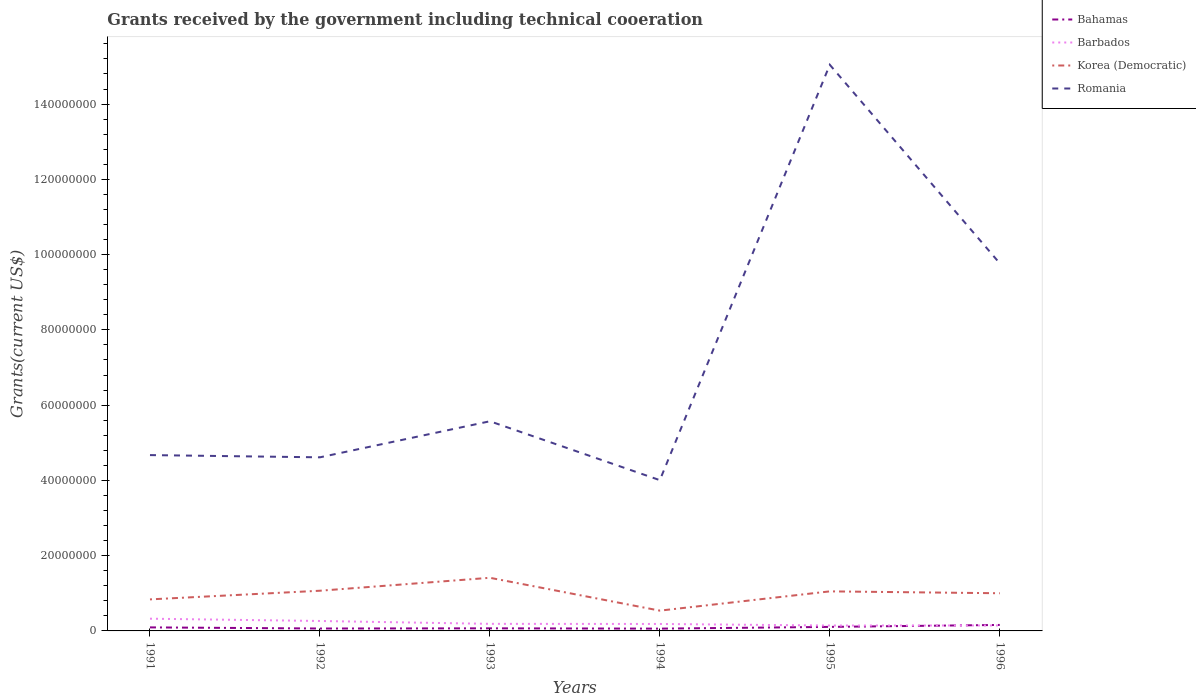Does the line corresponding to Bahamas intersect with the line corresponding to Korea (Democratic)?
Your answer should be very brief. No. Is the number of lines equal to the number of legend labels?
Offer a terse response. Yes. Across all years, what is the maximum total grants received by the government in Barbados?
Your answer should be very brief. 1.43e+06. What is the total total grants received by the government in Romania in the graph?
Offer a terse response. -9.47e+07. What is the difference between the highest and the second highest total grants received by the government in Barbados?
Your answer should be compact. 1.82e+06. What is the difference between the highest and the lowest total grants received by the government in Korea (Democratic)?
Your answer should be compact. 4. Is the total grants received by the government in Korea (Democratic) strictly greater than the total grants received by the government in Barbados over the years?
Provide a succinct answer. No. How are the legend labels stacked?
Keep it short and to the point. Vertical. What is the title of the graph?
Keep it short and to the point. Grants received by the government including technical cooeration. Does "Caribbean small states" appear as one of the legend labels in the graph?
Make the answer very short. No. What is the label or title of the X-axis?
Your response must be concise. Years. What is the label or title of the Y-axis?
Provide a succinct answer. Grants(current US$). What is the Grants(current US$) of Bahamas in 1991?
Keep it short and to the point. 9.40e+05. What is the Grants(current US$) in Barbados in 1991?
Provide a succinct answer. 3.25e+06. What is the Grants(current US$) in Korea (Democratic) in 1991?
Give a very brief answer. 8.38e+06. What is the Grants(current US$) of Romania in 1991?
Offer a very short reply. 4.67e+07. What is the Grants(current US$) in Bahamas in 1992?
Provide a succinct answer. 6.40e+05. What is the Grants(current US$) in Barbados in 1992?
Your response must be concise. 2.64e+06. What is the Grants(current US$) of Korea (Democratic) in 1992?
Give a very brief answer. 1.07e+07. What is the Grants(current US$) in Romania in 1992?
Offer a very short reply. 4.61e+07. What is the Grants(current US$) in Bahamas in 1993?
Give a very brief answer. 6.90e+05. What is the Grants(current US$) in Barbados in 1993?
Ensure brevity in your answer.  1.88e+06. What is the Grants(current US$) in Korea (Democratic) in 1993?
Provide a succinct answer. 1.41e+07. What is the Grants(current US$) of Romania in 1993?
Keep it short and to the point. 5.57e+07. What is the Grants(current US$) of Bahamas in 1994?
Your answer should be very brief. 6.10e+05. What is the Grants(current US$) of Barbados in 1994?
Your answer should be very brief. 1.85e+06. What is the Grants(current US$) of Korea (Democratic) in 1994?
Ensure brevity in your answer.  5.39e+06. What is the Grants(current US$) of Romania in 1994?
Keep it short and to the point. 4.01e+07. What is the Grants(current US$) of Bahamas in 1995?
Provide a succinct answer. 1.07e+06. What is the Grants(current US$) in Barbados in 1995?
Your answer should be very brief. 1.43e+06. What is the Grants(current US$) in Korea (Democratic) in 1995?
Your answer should be compact. 1.05e+07. What is the Grants(current US$) in Romania in 1995?
Offer a terse response. 1.50e+08. What is the Grants(current US$) in Bahamas in 1996?
Give a very brief answer. 1.59e+06. What is the Grants(current US$) of Barbados in 1996?
Ensure brevity in your answer.  1.45e+06. What is the Grants(current US$) in Korea (Democratic) in 1996?
Give a very brief answer. 1.00e+07. What is the Grants(current US$) in Romania in 1996?
Your answer should be very brief. 9.77e+07. Across all years, what is the maximum Grants(current US$) in Bahamas?
Provide a succinct answer. 1.59e+06. Across all years, what is the maximum Grants(current US$) of Barbados?
Ensure brevity in your answer.  3.25e+06. Across all years, what is the maximum Grants(current US$) of Korea (Democratic)?
Provide a short and direct response. 1.41e+07. Across all years, what is the maximum Grants(current US$) of Romania?
Make the answer very short. 1.50e+08. Across all years, what is the minimum Grants(current US$) in Bahamas?
Make the answer very short. 6.10e+05. Across all years, what is the minimum Grants(current US$) of Barbados?
Provide a succinct answer. 1.43e+06. Across all years, what is the minimum Grants(current US$) in Korea (Democratic)?
Provide a succinct answer. 5.39e+06. Across all years, what is the minimum Grants(current US$) in Romania?
Your answer should be very brief. 4.01e+07. What is the total Grants(current US$) of Bahamas in the graph?
Offer a very short reply. 5.54e+06. What is the total Grants(current US$) in Barbados in the graph?
Make the answer very short. 1.25e+07. What is the total Grants(current US$) of Korea (Democratic) in the graph?
Your answer should be compact. 5.91e+07. What is the total Grants(current US$) of Romania in the graph?
Give a very brief answer. 4.37e+08. What is the difference between the Grants(current US$) in Bahamas in 1991 and that in 1992?
Your answer should be very brief. 3.00e+05. What is the difference between the Grants(current US$) in Korea (Democratic) in 1991 and that in 1992?
Your answer should be compact. -2.30e+06. What is the difference between the Grants(current US$) in Romania in 1991 and that in 1992?
Offer a terse response. 5.90e+05. What is the difference between the Grants(current US$) of Bahamas in 1991 and that in 1993?
Offer a terse response. 2.50e+05. What is the difference between the Grants(current US$) of Barbados in 1991 and that in 1993?
Give a very brief answer. 1.37e+06. What is the difference between the Grants(current US$) in Korea (Democratic) in 1991 and that in 1993?
Offer a very short reply. -5.74e+06. What is the difference between the Grants(current US$) of Romania in 1991 and that in 1993?
Provide a short and direct response. -8.99e+06. What is the difference between the Grants(current US$) of Barbados in 1991 and that in 1994?
Your answer should be very brief. 1.40e+06. What is the difference between the Grants(current US$) in Korea (Democratic) in 1991 and that in 1994?
Offer a very short reply. 2.99e+06. What is the difference between the Grants(current US$) in Romania in 1991 and that in 1994?
Ensure brevity in your answer.  6.66e+06. What is the difference between the Grants(current US$) in Bahamas in 1991 and that in 1995?
Keep it short and to the point. -1.30e+05. What is the difference between the Grants(current US$) of Barbados in 1991 and that in 1995?
Offer a terse response. 1.82e+06. What is the difference between the Grants(current US$) of Korea (Democratic) in 1991 and that in 1995?
Give a very brief answer. -2.13e+06. What is the difference between the Grants(current US$) in Romania in 1991 and that in 1995?
Offer a very short reply. -1.04e+08. What is the difference between the Grants(current US$) of Bahamas in 1991 and that in 1996?
Your answer should be very brief. -6.50e+05. What is the difference between the Grants(current US$) in Barbados in 1991 and that in 1996?
Provide a succinct answer. 1.80e+06. What is the difference between the Grants(current US$) of Korea (Democratic) in 1991 and that in 1996?
Your response must be concise. -1.63e+06. What is the difference between the Grants(current US$) in Romania in 1991 and that in 1996?
Your answer should be very brief. -5.10e+07. What is the difference between the Grants(current US$) of Barbados in 1992 and that in 1993?
Keep it short and to the point. 7.60e+05. What is the difference between the Grants(current US$) of Korea (Democratic) in 1992 and that in 1993?
Your response must be concise. -3.44e+06. What is the difference between the Grants(current US$) of Romania in 1992 and that in 1993?
Offer a very short reply. -9.58e+06. What is the difference between the Grants(current US$) in Bahamas in 1992 and that in 1994?
Your answer should be very brief. 3.00e+04. What is the difference between the Grants(current US$) in Barbados in 1992 and that in 1994?
Give a very brief answer. 7.90e+05. What is the difference between the Grants(current US$) in Korea (Democratic) in 1992 and that in 1994?
Provide a short and direct response. 5.29e+06. What is the difference between the Grants(current US$) of Romania in 1992 and that in 1994?
Offer a very short reply. 6.07e+06. What is the difference between the Grants(current US$) in Bahamas in 1992 and that in 1995?
Make the answer very short. -4.30e+05. What is the difference between the Grants(current US$) of Barbados in 1992 and that in 1995?
Provide a succinct answer. 1.21e+06. What is the difference between the Grants(current US$) in Romania in 1992 and that in 1995?
Provide a succinct answer. -1.04e+08. What is the difference between the Grants(current US$) of Bahamas in 1992 and that in 1996?
Offer a terse response. -9.50e+05. What is the difference between the Grants(current US$) in Barbados in 1992 and that in 1996?
Offer a terse response. 1.19e+06. What is the difference between the Grants(current US$) of Korea (Democratic) in 1992 and that in 1996?
Provide a succinct answer. 6.70e+05. What is the difference between the Grants(current US$) of Romania in 1992 and that in 1996?
Ensure brevity in your answer.  -5.16e+07. What is the difference between the Grants(current US$) in Bahamas in 1993 and that in 1994?
Make the answer very short. 8.00e+04. What is the difference between the Grants(current US$) of Korea (Democratic) in 1993 and that in 1994?
Your response must be concise. 8.73e+06. What is the difference between the Grants(current US$) in Romania in 1993 and that in 1994?
Provide a short and direct response. 1.56e+07. What is the difference between the Grants(current US$) of Bahamas in 1993 and that in 1995?
Keep it short and to the point. -3.80e+05. What is the difference between the Grants(current US$) in Barbados in 1993 and that in 1995?
Provide a short and direct response. 4.50e+05. What is the difference between the Grants(current US$) of Korea (Democratic) in 1993 and that in 1995?
Ensure brevity in your answer.  3.61e+06. What is the difference between the Grants(current US$) in Romania in 1993 and that in 1995?
Your response must be concise. -9.47e+07. What is the difference between the Grants(current US$) of Bahamas in 1993 and that in 1996?
Provide a succinct answer. -9.00e+05. What is the difference between the Grants(current US$) of Barbados in 1993 and that in 1996?
Make the answer very short. 4.30e+05. What is the difference between the Grants(current US$) of Korea (Democratic) in 1993 and that in 1996?
Give a very brief answer. 4.11e+06. What is the difference between the Grants(current US$) in Romania in 1993 and that in 1996?
Give a very brief answer. -4.20e+07. What is the difference between the Grants(current US$) of Bahamas in 1994 and that in 1995?
Give a very brief answer. -4.60e+05. What is the difference between the Grants(current US$) of Barbados in 1994 and that in 1995?
Provide a short and direct response. 4.20e+05. What is the difference between the Grants(current US$) in Korea (Democratic) in 1994 and that in 1995?
Ensure brevity in your answer.  -5.12e+06. What is the difference between the Grants(current US$) of Romania in 1994 and that in 1995?
Make the answer very short. -1.10e+08. What is the difference between the Grants(current US$) of Bahamas in 1994 and that in 1996?
Offer a very short reply. -9.80e+05. What is the difference between the Grants(current US$) in Korea (Democratic) in 1994 and that in 1996?
Provide a succinct answer. -4.62e+06. What is the difference between the Grants(current US$) in Romania in 1994 and that in 1996?
Your response must be concise. -5.76e+07. What is the difference between the Grants(current US$) of Bahamas in 1995 and that in 1996?
Your answer should be compact. -5.20e+05. What is the difference between the Grants(current US$) of Korea (Democratic) in 1995 and that in 1996?
Your answer should be compact. 5.00e+05. What is the difference between the Grants(current US$) in Romania in 1995 and that in 1996?
Keep it short and to the point. 5.28e+07. What is the difference between the Grants(current US$) of Bahamas in 1991 and the Grants(current US$) of Barbados in 1992?
Offer a terse response. -1.70e+06. What is the difference between the Grants(current US$) of Bahamas in 1991 and the Grants(current US$) of Korea (Democratic) in 1992?
Your response must be concise. -9.74e+06. What is the difference between the Grants(current US$) of Bahamas in 1991 and the Grants(current US$) of Romania in 1992?
Make the answer very short. -4.52e+07. What is the difference between the Grants(current US$) in Barbados in 1991 and the Grants(current US$) in Korea (Democratic) in 1992?
Offer a very short reply. -7.43e+06. What is the difference between the Grants(current US$) of Barbados in 1991 and the Grants(current US$) of Romania in 1992?
Keep it short and to the point. -4.29e+07. What is the difference between the Grants(current US$) of Korea (Democratic) in 1991 and the Grants(current US$) of Romania in 1992?
Provide a succinct answer. -3.78e+07. What is the difference between the Grants(current US$) in Bahamas in 1991 and the Grants(current US$) in Barbados in 1993?
Provide a short and direct response. -9.40e+05. What is the difference between the Grants(current US$) of Bahamas in 1991 and the Grants(current US$) of Korea (Democratic) in 1993?
Provide a succinct answer. -1.32e+07. What is the difference between the Grants(current US$) of Bahamas in 1991 and the Grants(current US$) of Romania in 1993?
Provide a short and direct response. -5.48e+07. What is the difference between the Grants(current US$) in Barbados in 1991 and the Grants(current US$) in Korea (Democratic) in 1993?
Offer a very short reply. -1.09e+07. What is the difference between the Grants(current US$) of Barbados in 1991 and the Grants(current US$) of Romania in 1993?
Ensure brevity in your answer.  -5.25e+07. What is the difference between the Grants(current US$) of Korea (Democratic) in 1991 and the Grants(current US$) of Romania in 1993?
Your answer should be compact. -4.73e+07. What is the difference between the Grants(current US$) in Bahamas in 1991 and the Grants(current US$) in Barbados in 1994?
Your answer should be very brief. -9.10e+05. What is the difference between the Grants(current US$) in Bahamas in 1991 and the Grants(current US$) in Korea (Democratic) in 1994?
Ensure brevity in your answer.  -4.45e+06. What is the difference between the Grants(current US$) of Bahamas in 1991 and the Grants(current US$) of Romania in 1994?
Ensure brevity in your answer.  -3.91e+07. What is the difference between the Grants(current US$) in Barbados in 1991 and the Grants(current US$) in Korea (Democratic) in 1994?
Offer a terse response. -2.14e+06. What is the difference between the Grants(current US$) of Barbados in 1991 and the Grants(current US$) of Romania in 1994?
Keep it short and to the point. -3.68e+07. What is the difference between the Grants(current US$) in Korea (Democratic) in 1991 and the Grants(current US$) in Romania in 1994?
Keep it short and to the point. -3.17e+07. What is the difference between the Grants(current US$) of Bahamas in 1991 and the Grants(current US$) of Barbados in 1995?
Provide a short and direct response. -4.90e+05. What is the difference between the Grants(current US$) in Bahamas in 1991 and the Grants(current US$) in Korea (Democratic) in 1995?
Ensure brevity in your answer.  -9.57e+06. What is the difference between the Grants(current US$) in Bahamas in 1991 and the Grants(current US$) in Romania in 1995?
Ensure brevity in your answer.  -1.50e+08. What is the difference between the Grants(current US$) in Barbados in 1991 and the Grants(current US$) in Korea (Democratic) in 1995?
Your response must be concise. -7.26e+06. What is the difference between the Grants(current US$) of Barbados in 1991 and the Grants(current US$) of Romania in 1995?
Your answer should be very brief. -1.47e+08. What is the difference between the Grants(current US$) in Korea (Democratic) in 1991 and the Grants(current US$) in Romania in 1995?
Provide a short and direct response. -1.42e+08. What is the difference between the Grants(current US$) in Bahamas in 1991 and the Grants(current US$) in Barbados in 1996?
Your response must be concise. -5.10e+05. What is the difference between the Grants(current US$) of Bahamas in 1991 and the Grants(current US$) of Korea (Democratic) in 1996?
Provide a succinct answer. -9.07e+06. What is the difference between the Grants(current US$) of Bahamas in 1991 and the Grants(current US$) of Romania in 1996?
Your answer should be compact. -9.67e+07. What is the difference between the Grants(current US$) in Barbados in 1991 and the Grants(current US$) in Korea (Democratic) in 1996?
Ensure brevity in your answer.  -6.76e+06. What is the difference between the Grants(current US$) in Barbados in 1991 and the Grants(current US$) in Romania in 1996?
Offer a terse response. -9.44e+07. What is the difference between the Grants(current US$) in Korea (Democratic) in 1991 and the Grants(current US$) in Romania in 1996?
Offer a terse response. -8.93e+07. What is the difference between the Grants(current US$) in Bahamas in 1992 and the Grants(current US$) in Barbados in 1993?
Your answer should be compact. -1.24e+06. What is the difference between the Grants(current US$) of Bahamas in 1992 and the Grants(current US$) of Korea (Democratic) in 1993?
Keep it short and to the point. -1.35e+07. What is the difference between the Grants(current US$) in Bahamas in 1992 and the Grants(current US$) in Romania in 1993?
Ensure brevity in your answer.  -5.51e+07. What is the difference between the Grants(current US$) in Barbados in 1992 and the Grants(current US$) in Korea (Democratic) in 1993?
Offer a terse response. -1.15e+07. What is the difference between the Grants(current US$) in Barbados in 1992 and the Grants(current US$) in Romania in 1993?
Provide a succinct answer. -5.31e+07. What is the difference between the Grants(current US$) in Korea (Democratic) in 1992 and the Grants(current US$) in Romania in 1993?
Provide a short and direct response. -4.50e+07. What is the difference between the Grants(current US$) in Bahamas in 1992 and the Grants(current US$) in Barbados in 1994?
Give a very brief answer. -1.21e+06. What is the difference between the Grants(current US$) of Bahamas in 1992 and the Grants(current US$) of Korea (Democratic) in 1994?
Keep it short and to the point. -4.75e+06. What is the difference between the Grants(current US$) in Bahamas in 1992 and the Grants(current US$) in Romania in 1994?
Give a very brief answer. -3.94e+07. What is the difference between the Grants(current US$) in Barbados in 1992 and the Grants(current US$) in Korea (Democratic) in 1994?
Provide a short and direct response. -2.75e+06. What is the difference between the Grants(current US$) of Barbados in 1992 and the Grants(current US$) of Romania in 1994?
Provide a short and direct response. -3.74e+07. What is the difference between the Grants(current US$) of Korea (Democratic) in 1992 and the Grants(current US$) of Romania in 1994?
Offer a terse response. -2.94e+07. What is the difference between the Grants(current US$) in Bahamas in 1992 and the Grants(current US$) in Barbados in 1995?
Provide a short and direct response. -7.90e+05. What is the difference between the Grants(current US$) of Bahamas in 1992 and the Grants(current US$) of Korea (Democratic) in 1995?
Offer a very short reply. -9.87e+06. What is the difference between the Grants(current US$) in Bahamas in 1992 and the Grants(current US$) in Romania in 1995?
Your answer should be very brief. -1.50e+08. What is the difference between the Grants(current US$) of Barbados in 1992 and the Grants(current US$) of Korea (Democratic) in 1995?
Provide a succinct answer. -7.87e+06. What is the difference between the Grants(current US$) of Barbados in 1992 and the Grants(current US$) of Romania in 1995?
Make the answer very short. -1.48e+08. What is the difference between the Grants(current US$) in Korea (Democratic) in 1992 and the Grants(current US$) in Romania in 1995?
Provide a succinct answer. -1.40e+08. What is the difference between the Grants(current US$) of Bahamas in 1992 and the Grants(current US$) of Barbados in 1996?
Give a very brief answer. -8.10e+05. What is the difference between the Grants(current US$) of Bahamas in 1992 and the Grants(current US$) of Korea (Democratic) in 1996?
Offer a very short reply. -9.37e+06. What is the difference between the Grants(current US$) of Bahamas in 1992 and the Grants(current US$) of Romania in 1996?
Your answer should be compact. -9.70e+07. What is the difference between the Grants(current US$) of Barbados in 1992 and the Grants(current US$) of Korea (Democratic) in 1996?
Provide a succinct answer. -7.37e+06. What is the difference between the Grants(current US$) in Barbados in 1992 and the Grants(current US$) in Romania in 1996?
Provide a succinct answer. -9.50e+07. What is the difference between the Grants(current US$) of Korea (Democratic) in 1992 and the Grants(current US$) of Romania in 1996?
Keep it short and to the point. -8.70e+07. What is the difference between the Grants(current US$) of Bahamas in 1993 and the Grants(current US$) of Barbados in 1994?
Provide a succinct answer. -1.16e+06. What is the difference between the Grants(current US$) in Bahamas in 1993 and the Grants(current US$) in Korea (Democratic) in 1994?
Your response must be concise. -4.70e+06. What is the difference between the Grants(current US$) in Bahamas in 1993 and the Grants(current US$) in Romania in 1994?
Your answer should be very brief. -3.94e+07. What is the difference between the Grants(current US$) in Barbados in 1993 and the Grants(current US$) in Korea (Democratic) in 1994?
Your answer should be very brief. -3.51e+06. What is the difference between the Grants(current US$) of Barbados in 1993 and the Grants(current US$) of Romania in 1994?
Your answer should be compact. -3.82e+07. What is the difference between the Grants(current US$) of Korea (Democratic) in 1993 and the Grants(current US$) of Romania in 1994?
Offer a terse response. -2.59e+07. What is the difference between the Grants(current US$) of Bahamas in 1993 and the Grants(current US$) of Barbados in 1995?
Keep it short and to the point. -7.40e+05. What is the difference between the Grants(current US$) in Bahamas in 1993 and the Grants(current US$) in Korea (Democratic) in 1995?
Provide a succinct answer. -9.82e+06. What is the difference between the Grants(current US$) of Bahamas in 1993 and the Grants(current US$) of Romania in 1995?
Ensure brevity in your answer.  -1.50e+08. What is the difference between the Grants(current US$) in Barbados in 1993 and the Grants(current US$) in Korea (Democratic) in 1995?
Keep it short and to the point. -8.63e+06. What is the difference between the Grants(current US$) of Barbados in 1993 and the Grants(current US$) of Romania in 1995?
Your answer should be compact. -1.49e+08. What is the difference between the Grants(current US$) of Korea (Democratic) in 1993 and the Grants(current US$) of Romania in 1995?
Ensure brevity in your answer.  -1.36e+08. What is the difference between the Grants(current US$) of Bahamas in 1993 and the Grants(current US$) of Barbados in 1996?
Keep it short and to the point. -7.60e+05. What is the difference between the Grants(current US$) of Bahamas in 1993 and the Grants(current US$) of Korea (Democratic) in 1996?
Offer a terse response. -9.32e+06. What is the difference between the Grants(current US$) of Bahamas in 1993 and the Grants(current US$) of Romania in 1996?
Offer a very short reply. -9.70e+07. What is the difference between the Grants(current US$) in Barbados in 1993 and the Grants(current US$) in Korea (Democratic) in 1996?
Provide a short and direct response. -8.13e+06. What is the difference between the Grants(current US$) of Barbados in 1993 and the Grants(current US$) of Romania in 1996?
Give a very brief answer. -9.58e+07. What is the difference between the Grants(current US$) of Korea (Democratic) in 1993 and the Grants(current US$) of Romania in 1996?
Your answer should be very brief. -8.36e+07. What is the difference between the Grants(current US$) of Bahamas in 1994 and the Grants(current US$) of Barbados in 1995?
Offer a very short reply. -8.20e+05. What is the difference between the Grants(current US$) in Bahamas in 1994 and the Grants(current US$) in Korea (Democratic) in 1995?
Provide a succinct answer. -9.90e+06. What is the difference between the Grants(current US$) in Bahamas in 1994 and the Grants(current US$) in Romania in 1995?
Provide a succinct answer. -1.50e+08. What is the difference between the Grants(current US$) in Barbados in 1994 and the Grants(current US$) in Korea (Democratic) in 1995?
Provide a succinct answer. -8.66e+06. What is the difference between the Grants(current US$) in Barbados in 1994 and the Grants(current US$) in Romania in 1995?
Your response must be concise. -1.49e+08. What is the difference between the Grants(current US$) of Korea (Democratic) in 1994 and the Grants(current US$) of Romania in 1995?
Ensure brevity in your answer.  -1.45e+08. What is the difference between the Grants(current US$) of Bahamas in 1994 and the Grants(current US$) of Barbados in 1996?
Provide a short and direct response. -8.40e+05. What is the difference between the Grants(current US$) of Bahamas in 1994 and the Grants(current US$) of Korea (Democratic) in 1996?
Offer a terse response. -9.40e+06. What is the difference between the Grants(current US$) in Bahamas in 1994 and the Grants(current US$) in Romania in 1996?
Keep it short and to the point. -9.71e+07. What is the difference between the Grants(current US$) in Barbados in 1994 and the Grants(current US$) in Korea (Democratic) in 1996?
Give a very brief answer. -8.16e+06. What is the difference between the Grants(current US$) in Barbados in 1994 and the Grants(current US$) in Romania in 1996?
Ensure brevity in your answer.  -9.58e+07. What is the difference between the Grants(current US$) of Korea (Democratic) in 1994 and the Grants(current US$) of Romania in 1996?
Ensure brevity in your answer.  -9.23e+07. What is the difference between the Grants(current US$) in Bahamas in 1995 and the Grants(current US$) in Barbados in 1996?
Offer a terse response. -3.80e+05. What is the difference between the Grants(current US$) in Bahamas in 1995 and the Grants(current US$) in Korea (Democratic) in 1996?
Give a very brief answer. -8.94e+06. What is the difference between the Grants(current US$) of Bahamas in 1995 and the Grants(current US$) of Romania in 1996?
Provide a short and direct response. -9.66e+07. What is the difference between the Grants(current US$) in Barbados in 1995 and the Grants(current US$) in Korea (Democratic) in 1996?
Make the answer very short. -8.58e+06. What is the difference between the Grants(current US$) in Barbados in 1995 and the Grants(current US$) in Romania in 1996?
Ensure brevity in your answer.  -9.62e+07. What is the difference between the Grants(current US$) of Korea (Democratic) in 1995 and the Grants(current US$) of Romania in 1996?
Provide a succinct answer. -8.72e+07. What is the average Grants(current US$) of Bahamas per year?
Your answer should be compact. 9.23e+05. What is the average Grants(current US$) of Barbados per year?
Keep it short and to the point. 2.08e+06. What is the average Grants(current US$) in Korea (Democratic) per year?
Make the answer very short. 9.85e+06. What is the average Grants(current US$) in Romania per year?
Offer a very short reply. 7.28e+07. In the year 1991, what is the difference between the Grants(current US$) in Bahamas and Grants(current US$) in Barbados?
Your response must be concise. -2.31e+06. In the year 1991, what is the difference between the Grants(current US$) in Bahamas and Grants(current US$) in Korea (Democratic)?
Keep it short and to the point. -7.44e+06. In the year 1991, what is the difference between the Grants(current US$) of Bahamas and Grants(current US$) of Romania?
Offer a terse response. -4.58e+07. In the year 1991, what is the difference between the Grants(current US$) of Barbados and Grants(current US$) of Korea (Democratic)?
Provide a short and direct response. -5.13e+06. In the year 1991, what is the difference between the Grants(current US$) in Barbados and Grants(current US$) in Romania?
Your answer should be compact. -4.35e+07. In the year 1991, what is the difference between the Grants(current US$) in Korea (Democratic) and Grants(current US$) in Romania?
Your response must be concise. -3.83e+07. In the year 1992, what is the difference between the Grants(current US$) in Bahamas and Grants(current US$) in Barbados?
Ensure brevity in your answer.  -2.00e+06. In the year 1992, what is the difference between the Grants(current US$) in Bahamas and Grants(current US$) in Korea (Democratic)?
Provide a succinct answer. -1.00e+07. In the year 1992, what is the difference between the Grants(current US$) in Bahamas and Grants(current US$) in Romania?
Make the answer very short. -4.55e+07. In the year 1992, what is the difference between the Grants(current US$) of Barbados and Grants(current US$) of Korea (Democratic)?
Your response must be concise. -8.04e+06. In the year 1992, what is the difference between the Grants(current US$) of Barbados and Grants(current US$) of Romania?
Give a very brief answer. -4.35e+07. In the year 1992, what is the difference between the Grants(current US$) in Korea (Democratic) and Grants(current US$) in Romania?
Your response must be concise. -3.54e+07. In the year 1993, what is the difference between the Grants(current US$) in Bahamas and Grants(current US$) in Barbados?
Make the answer very short. -1.19e+06. In the year 1993, what is the difference between the Grants(current US$) in Bahamas and Grants(current US$) in Korea (Democratic)?
Make the answer very short. -1.34e+07. In the year 1993, what is the difference between the Grants(current US$) of Bahamas and Grants(current US$) of Romania?
Make the answer very short. -5.50e+07. In the year 1993, what is the difference between the Grants(current US$) of Barbados and Grants(current US$) of Korea (Democratic)?
Ensure brevity in your answer.  -1.22e+07. In the year 1993, what is the difference between the Grants(current US$) of Barbados and Grants(current US$) of Romania?
Keep it short and to the point. -5.38e+07. In the year 1993, what is the difference between the Grants(current US$) in Korea (Democratic) and Grants(current US$) in Romania?
Give a very brief answer. -4.16e+07. In the year 1994, what is the difference between the Grants(current US$) in Bahamas and Grants(current US$) in Barbados?
Give a very brief answer. -1.24e+06. In the year 1994, what is the difference between the Grants(current US$) of Bahamas and Grants(current US$) of Korea (Democratic)?
Ensure brevity in your answer.  -4.78e+06. In the year 1994, what is the difference between the Grants(current US$) of Bahamas and Grants(current US$) of Romania?
Your response must be concise. -3.94e+07. In the year 1994, what is the difference between the Grants(current US$) of Barbados and Grants(current US$) of Korea (Democratic)?
Ensure brevity in your answer.  -3.54e+06. In the year 1994, what is the difference between the Grants(current US$) in Barbados and Grants(current US$) in Romania?
Ensure brevity in your answer.  -3.82e+07. In the year 1994, what is the difference between the Grants(current US$) in Korea (Democratic) and Grants(current US$) in Romania?
Provide a short and direct response. -3.47e+07. In the year 1995, what is the difference between the Grants(current US$) of Bahamas and Grants(current US$) of Barbados?
Ensure brevity in your answer.  -3.60e+05. In the year 1995, what is the difference between the Grants(current US$) in Bahamas and Grants(current US$) in Korea (Democratic)?
Offer a terse response. -9.44e+06. In the year 1995, what is the difference between the Grants(current US$) of Bahamas and Grants(current US$) of Romania?
Give a very brief answer. -1.49e+08. In the year 1995, what is the difference between the Grants(current US$) in Barbados and Grants(current US$) in Korea (Democratic)?
Offer a terse response. -9.08e+06. In the year 1995, what is the difference between the Grants(current US$) of Barbados and Grants(current US$) of Romania?
Keep it short and to the point. -1.49e+08. In the year 1995, what is the difference between the Grants(current US$) of Korea (Democratic) and Grants(current US$) of Romania?
Your response must be concise. -1.40e+08. In the year 1996, what is the difference between the Grants(current US$) in Bahamas and Grants(current US$) in Barbados?
Make the answer very short. 1.40e+05. In the year 1996, what is the difference between the Grants(current US$) of Bahamas and Grants(current US$) of Korea (Democratic)?
Give a very brief answer. -8.42e+06. In the year 1996, what is the difference between the Grants(current US$) of Bahamas and Grants(current US$) of Romania?
Give a very brief answer. -9.61e+07. In the year 1996, what is the difference between the Grants(current US$) of Barbados and Grants(current US$) of Korea (Democratic)?
Your answer should be compact. -8.56e+06. In the year 1996, what is the difference between the Grants(current US$) of Barbados and Grants(current US$) of Romania?
Keep it short and to the point. -9.62e+07. In the year 1996, what is the difference between the Grants(current US$) in Korea (Democratic) and Grants(current US$) in Romania?
Your response must be concise. -8.77e+07. What is the ratio of the Grants(current US$) in Bahamas in 1991 to that in 1992?
Provide a succinct answer. 1.47. What is the ratio of the Grants(current US$) of Barbados in 1991 to that in 1992?
Your response must be concise. 1.23. What is the ratio of the Grants(current US$) in Korea (Democratic) in 1991 to that in 1992?
Give a very brief answer. 0.78. What is the ratio of the Grants(current US$) of Romania in 1991 to that in 1992?
Provide a succinct answer. 1.01. What is the ratio of the Grants(current US$) of Bahamas in 1991 to that in 1993?
Ensure brevity in your answer.  1.36. What is the ratio of the Grants(current US$) of Barbados in 1991 to that in 1993?
Keep it short and to the point. 1.73. What is the ratio of the Grants(current US$) of Korea (Democratic) in 1991 to that in 1993?
Offer a very short reply. 0.59. What is the ratio of the Grants(current US$) in Romania in 1991 to that in 1993?
Offer a terse response. 0.84. What is the ratio of the Grants(current US$) in Bahamas in 1991 to that in 1994?
Provide a short and direct response. 1.54. What is the ratio of the Grants(current US$) of Barbados in 1991 to that in 1994?
Your answer should be very brief. 1.76. What is the ratio of the Grants(current US$) of Korea (Democratic) in 1991 to that in 1994?
Offer a terse response. 1.55. What is the ratio of the Grants(current US$) in Romania in 1991 to that in 1994?
Offer a terse response. 1.17. What is the ratio of the Grants(current US$) in Bahamas in 1991 to that in 1995?
Provide a short and direct response. 0.88. What is the ratio of the Grants(current US$) of Barbados in 1991 to that in 1995?
Offer a very short reply. 2.27. What is the ratio of the Grants(current US$) in Korea (Democratic) in 1991 to that in 1995?
Your answer should be very brief. 0.8. What is the ratio of the Grants(current US$) in Romania in 1991 to that in 1995?
Your response must be concise. 0.31. What is the ratio of the Grants(current US$) of Bahamas in 1991 to that in 1996?
Offer a terse response. 0.59. What is the ratio of the Grants(current US$) in Barbados in 1991 to that in 1996?
Your answer should be very brief. 2.24. What is the ratio of the Grants(current US$) in Korea (Democratic) in 1991 to that in 1996?
Offer a terse response. 0.84. What is the ratio of the Grants(current US$) in Romania in 1991 to that in 1996?
Provide a succinct answer. 0.48. What is the ratio of the Grants(current US$) in Bahamas in 1992 to that in 1993?
Offer a terse response. 0.93. What is the ratio of the Grants(current US$) of Barbados in 1992 to that in 1993?
Offer a terse response. 1.4. What is the ratio of the Grants(current US$) of Korea (Democratic) in 1992 to that in 1993?
Your response must be concise. 0.76. What is the ratio of the Grants(current US$) in Romania in 1992 to that in 1993?
Your response must be concise. 0.83. What is the ratio of the Grants(current US$) of Bahamas in 1992 to that in 1994?
Your answer should be very brief. 1.05. What is the ratio of the Grants(current US$) of Barbados in 1992 to that in 1994?
Make the answer very short. 1.43. What is the ratio of the Grants(current US$) of Korea (Democratic) in 1992 to that in 1994?
Provide a short and direct response. 1.98. What is the ratio of the Grants(current US$) in Romania in 1992 to that in 1994?
Give a very brief answer. 1.15. What is the ratio of the Grants(current US$) in Bahamas in 1992 to that in 1995?
Provide a succinct answer. 0.6. What is the ratio of the Grants(current US$) of Barbados in 1992 to that in 1995?
Your answer should be very brief. 1.85. What is the ratio of the Grants(current US$) in Korea (Democratic) in 1992 to that in 1995?
Ensure brevity in your answer.  1.02. What is the ratio of the Grants(current US$) in Romania in 1992 to that in 1995?
Offer a very short reply. 0.31. What is the ratio of the Grants(current US$) of Bahamas in 1992 to that in 1996?
Provide a succinct answer. 0.4. What is the ratio of the Grants(current US$) in Barbados in 1992 to that in 1996?
Offer a terse response. 1.82. What is the ratio of the Grants(current US$) in Korea (Democratic) in 1992 to that in 1996?
Offer a terse response. 1.07. What is the ratio of the Grants(current US$) of Romania in 1992 to that in 1996?
Offer a very short reply. 0.47. What is the ratio of the Grants(current US$) of Bahamas in 1993 to that in 1994?
Provide a short and direct response. 1.13. What is the ratio of the Grants(current US$) in Barbados in 1993 to that in 1994?
Provide a succinct answer. 1.02. What is the ratio of the Grants(current US$) of Korea (Democratic) in 1993 to that in 1994?
Provide a succinct answer. 2.62. What is the ratio of the Grants(current US$) in Romania in 1993 to that in 1994?
Offer a terse response. 1.39. What is the ratio of the Grants(current US$) of Bahamas in 1993 to that in 1995?
Offer a terse response. 0.64. What is the ratio of the Grants(current US$) in Barbados in 1993 to that in 1995?
Offer a very short reply. 1.31. What is the ratio of the Grants(current US$) of Korea (Democratic) in 1993 to that in 1995?
Provide a succinct answer. 1.34. What is the ratio of the Grants(current US$) of Romania in 1993 to that in 1995?
Your answer should be very brief. 0.37. What is the ratio of the Grants(current US$) of Bahamas in 1993 to that in 1996?
Provide a succinct answer. 0.43. What is the ratio of the Grants(current US$) of Barbados in 1993 to that in 1996?
Your answer should be very brief. 1.3. What is the ratio of the Grants(current US$) in Korea (Democratic) in 1993 to that in 1996?
Offer a very short reply. 1.41. What is the ratio of the Grants(current US$) of Romania in 1993 to that in 1996?
Offer a terse response. 0.57. What is the ratio of the Grants(current US$) in Bahamas in 1994 to that in 1995?
Provide a succinct answer. 0.57. What is the ratio of the Grants(current US$) in Barbados in 1994 to that in 1995?
Keep it short and to the point. 1.29. What is the ratio of the Grants(current US$) of Korea (Democratic) in 1994 to that in 1995?
Your answer should be compact. 0.51. What is the ratio of the Grants(current US$) of Romania in 1994 to that in 1995?
Make the answer very short. 0.27. What is the ratio of the Grants(current US$) in Bahamas in 1994 to that in 1996?
Provide a short and direct response. 0.38. What is the ratio of the Grants(current US$) of Barbados in 1994 to that in 1996?
Make the answer very short. 1.28. What is the ratio of the Grants(current US$) of Korea (Democratic) in 1994 to that in 1996?
Give a very brief answer. 0.54. What is the ratio of the Grants(current US$) in Romania in 1994 to that in 1996?
Your answer should be compact. 0.41. What is the ratio of the Grants(current US$) of Bahamas in 1995 to that in 1996?
Your response must be concise. 0.67. What is the ratio of the Grants(current US$) in Barbados in 1995 to that in 1996?
Give a very brief answer. 0.99. What is the ratio of the Grants(current US$) in Romania in 1995 to that in 1996?
Make the answer very short. 1.54. What is the difference between the highest and the second highest Grants(current US$) in Bahamas?
Your answer should be very brief. 5.20e+05. What is the difference between the highest and the second highest Grants(current US$) in Korea (Democratic)?
Your response must be concise. 3.44e+06. What is the difference between the highest and the second highest Grants(current US$) in Romania?
Keep it short and to the point. 5.28e+07. What is the difference between the highest and the lowest Grants(current US$) of Bahamas?
Provide a succinct answer. 9.80e+05. What is the difference between the highest and the lowest Grants(current US$) in Barbados?
Give a very brief answer. 1.82e+06. What is the difference between the highest and the lowest Grants(current US$) of Korea (Democratic)?
Offer a terse response. 8.73e+06. What is the difference between the highest and the lowest Grants(current US$) in Romania?
Offer a terse response. 1.10e+08. 